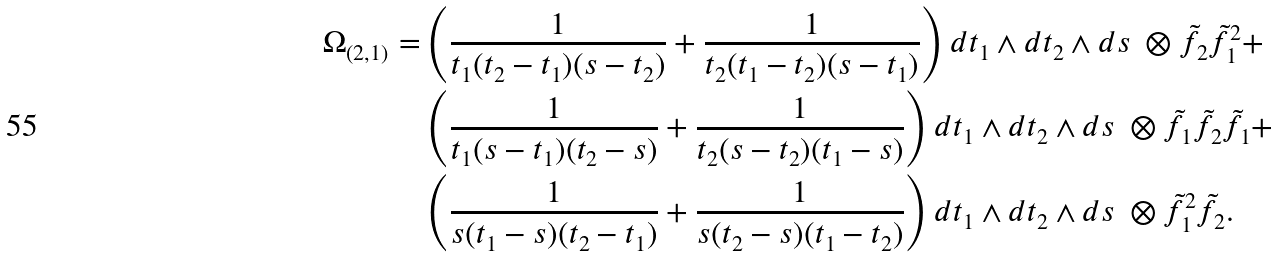Convert formula to latex. <formula><loc_0><loc_0><loc_500><loc_500>\Omega _ { ( 2 , 1 ) } = & \left ( \frac { 1 } { t _ { 1 } ( t _ { 2 } - t _ { 1 } ) ( s - t _ { 2 } ) } + \frac { 1 } { t _ { 2 } ( t _ { 1 } - t _ { 2 } ) ( s - t _ { 1 } ) } \right ) d t _ { 1 } \wedge d t _ { 2 } \wedge d s \ \otimes \tilde { f } _ { 2 } \tilde { f } _ { 1 } ^ { 2 } + \\ & \left ( \frac { 1 } { t _ { 1 } ( s - t _ { 1 } ) ( t _ { 2 } - s ) } + \frac { 1 } { t _ { 2 } ( s - t _ { 2 } ) ( t _ { 1 } - s ) } \right ) d t _ { 1 } \wedge d t _ { 2 } \wedge d s \ \otimes \tilde { f } _ { 1 } \tilde { f } _ { 2 } \tilde { f } _ { 1 } + \\ & \left ( \frac { 1 } { s ( t _ { 1 } - s ) ( t _ { 2 } - t _ { 1 } ) } + \frac { 1 } { s ( t _ { 2 } - s ) ( t _ { 1 } - t _ { 2 } ) } \right ) d t _ { 1 } \wedge d t _ { 2 } \wedge d s \ \otimes \tilde { f } _ { 1 } ^ { 2 } \tilde { f } _ { 2 } .</formula> 